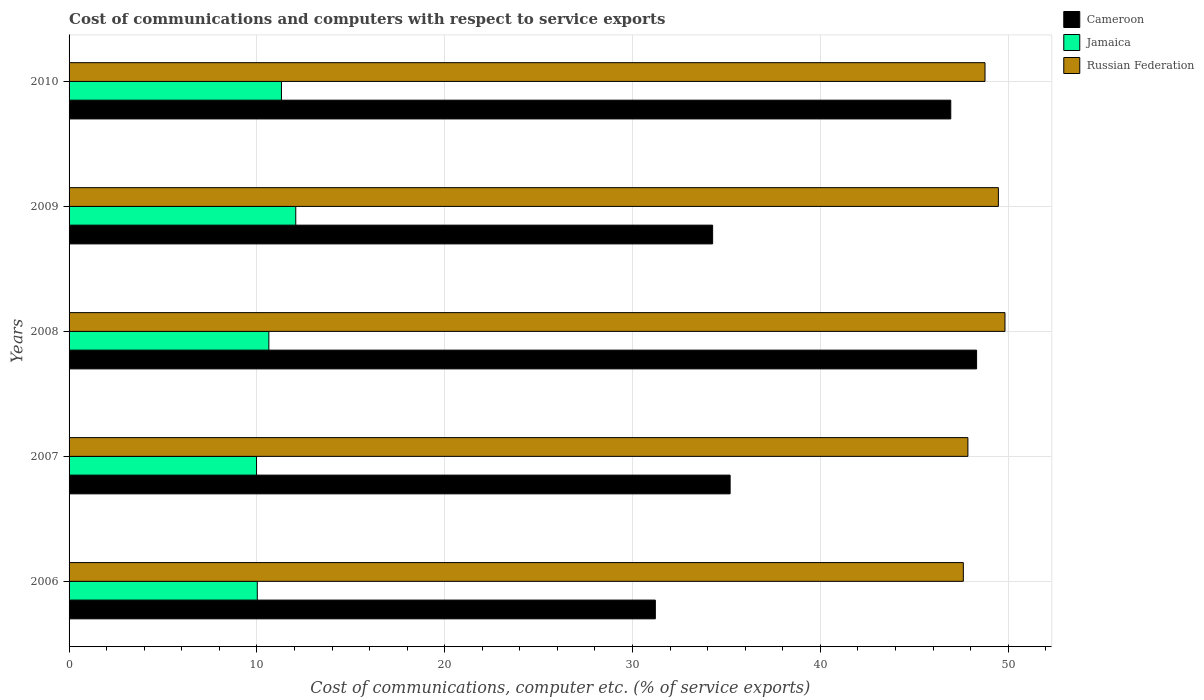How many different coloured bars are there?
Provide a succinct answer. 3. How many groups of bars are there?
Give a very brief answer. 5. How many bars are there on the 5th tick from the bottom?
Make the answer very short. 3. What is the label of the 4th group of bars from the top?
Your response must be concise. 2007. What is the cost of communications and computers in Jamaica in 2006?
Your response must be concise. 10.02. Across all years, what is the maximum cost of communications and computers in Russian Federation?
Offer a very short reply. 49.83. Across all years, what is the minimum cost of communications and computers in Jamaica?
Your response must be concise. 9.98. In which year was the cost of communications and computers in Russian Federation maximum?
Offer a very short reply. 2008. In which year was the cost of communications and computers in Cameroon minimum?
Your response must be concise. 2006. What is the total cost of communications and computers in Russian Federation in the graph?
Provide a succinct answer. 243.55. What is the difference between the cost of communications and computers in Cameroon in 2006 and that in 2007?
Your response must be concise. -3.98. What is the difference between the cost of communications and computers in Cameroon in 2006 and the cost of communications and computers in Russian Federation in 2007?
Offer a terse response. -16.64. What is the average cost of communications and computers in Russian Federation per year?
Make the answer very short. 48.71. In the year 2006, what is the difference between the cost of communications and computers in Jamaica and cost of communications and computers in Cameroon?
Ensure brevity in your answer.  -21.19. In how many years, is the cost of communications and computers in Russian Federation greater than 18 %?
Provide a succinct answer. 5. What is the ratio of the cost of communications and computers in Russian Federation in 2007 to that in 2009?
Make the answer very short. 0.97. Is the difference between the cost of communications and computers in Jamaica in 2007 and 2008 greater than the difference between the cost of communications and computers in Cameroon in 2007 and 2008?
Your answer should be compact. Yes. What is the difference between the highest and the second highest cost of communications and computers in Jamaica?
Your answer should be very brief. 0.76. What is the difference between the highest and the lowest cost of communications and computers in Jamaica?
Give a very brief answer. 2.09. In how many years, is the cost of communications and computers in Cameroon greater than the average cost of communications and computers in Cameroon taken over all years?
Provide a succinct answer. 2. What does the 3rd bar from the top in 2006 represents?
Provide a succinct answer. Cameroon. What does the 2nd bar from the bottom in 2008 represents?
Offer a very short reply. Jamaica. Is it the case that in every year, the sum of the cost of communications and computers in Russian Federation and cost of communications and computers in Cameroon is greater than the cost of communications and computers in Jamaica?
Make the answer very short. Yes. How many bars are there?
Your answer should be compact. 15. Are all the bars in the graph horizontal?
Give a very brief answer. Yes. How many years are there in the graph?
Your answer should be compact. 5. Does the graph contain any zero values?
Keep it short and to the point. No. What is the title of the graph?
Provide a short and direct response. Cost of communications and computers with respect to service exports. What is the label or title of the X-axis?
Provide a succinct answer. Cost of communications, computer etc. (% of service exports). What is the label or title of the Y-axis?
Your answer should be very brief. Years. What is the Cost of communications, computer etc. (% of service exports) of Cameroon in 2006?
Your response must be concise. 31.22. What is the Cost of communications, computer etc. (% of service exports) of Jamaica in 2006?
Your answer should be very brief. 10.02. What is the Cost of communications, computer etc. (% of service exports) of Russian Federation in 2006?
Your answer should be compact. 47.61. What is the Cost of communications, computer etc. (% of service exports) in Cameroon in 2007?
Your response must be concise. 35.2. What is the Cost of communications, computer etc. (% of service exports) of Jamaica in 2007?
Make the answer very short. 9.98. What is the Cost of communications, computer etc. (% of service exports) in Russian Federation in 2007?
Make the answer very short. 47.86. What is the Cost of communications, computer etc. (% of service exports) in Cameroon in 2008?
Your answer should be compact. 48.32. What is the Cost of communications, computer etc. (% of service exports) in Jamaica in 2008?
Offer a very short reply. 10.64. What is the Cost of communications, computer etc. (% of service exports) of Russian Federation in 2008?
Offer a very short reply. 49.83. What is the Cost of communications, computer etc. (% of service exports) in Cameroon in 2009?
Offer a very short reply. 34.27. What is the Cost of communications, computer etc. (% of service exports) of Jamaica in 2009?
Provide a succinct answer. 12.07. What is the Cost of communications, computer etc. (% of service exports) of Russian Federation in 2009?
Your answer should be compact. 49.48. What is the Cost of communications, computer etc. (% of service exports) in Cameroon in 2010?
Make the answer very short. 46.95. What is the Cost of communications, computer etc. (% of service exports) of Jamaica in 2010?
Offer a terse response. 11.31. What is the Cost of communications, computer etc. (% of service exports) in Russian Federation in 2010?
Offer a terse response. 48.77. Across all years, what is the maximum Cost of communications, computer etc. (% of service exports) of Cameroon?
Your answer should be very brief. 48.32. Across all years, what is the maximum Cost of communications, computer etc. (% of service exports) of Jamaica?
Your response must be concise. 12.07. Across all years, what is the maximum Cost of communications, computer etc. (% of service exports) in Russian Federation?
Offer a very short reply. 49.83. Across all years, what is the minimum Cost of communications, computer etc. (% of service exports) of Cameroon?
Offer a terse response. 31.22. Across all years, what is the minimum Cost of communications, computer etc. (% of service exports) of Jamaica?
Ensure brevity in your answer.  9.98. Across all years, what is the minimum Cost of communications, computer etc. (% of service exports) in Russian Federation?
Offer a terse response. 47.61. What is the total Cost of communications, computer etc. (% of service exports) of Cameroon in the graph?
Your answer should be very brief. 195.94. What is the total Cost of communications, computer etc. (% of service exports) of Jamaica in the graph?
Provide a succinct answer. 54.02. What is the total Cost of communications, computer etc. (% of service exports) of Russian Federation in the graph?
Offer a very short reply. 243.55. What is the difference between the Cost of communications, computer etc. (% of service exports) of Cameroon in 2006 and that in 2007?
Offer a terse response. -3.98. What is the difference between the Cost of communications, computer etc. (% of service exports) of Jamaica in 2006 and that in 2007?
Offer a very short reply. 0.04. What is the difference between the Cost of communications, computer etc. (% of service exports) in Russian Federation in 2006 and that in 2007?
Your answer should be compact. -0.24. What is the difference between the Cost of communications, computer etc. (% of service exports) of Cameroon in 2006 and that in 2008?
Offer a terse response. -17.11. What is the difference between the Cost of communications, computer etc. (% of service exports) of Jamaica in 2006 and that in 2008?
Make the answer very short. -0.62. What is the difference between the Cost of communications, computer etc. (% of service exports) in Russian Federation in 2006 and that in 2008?
Your answer should be very brief. -2.22. What is the difference between the Cost of communications, computer etc. (% of service exports) in Cameroon in 2006 and that in 2009?
Provide a succinct answer. -3.05. What is the difference between the Cost of communications, computer etc. (% of service exports) of Jamaica in 2006 and that in 2009?
Offer a very short reply. -2.05. What is the difference between the Cost of communications, computer etc. (% of service exports) of Russian Federation in 2006 and that in 2009?
Your response must be concise. -1.87. What is the difference between the Cost of communications, computer etc. (% of service exports) in Cameroon in 2006 and that in 2010?
Ensure brevity in your answer.  -15.73. What is the difference between the Cost of communications, computer etc. (% of service exports) in Jamaica in 2006 and that in 2010?
Give a very brief answer. -1.29. What is the difference between the Cost of communications, computer etc. (% of service exports) of Russian Federation in 2006 and that in 2010?
Provide a succinct answer. -1.15. What is the difference between the Cost of communications, computer etc. (% of service exports) of Cameroon in 2007 and that in 2008?
Your answer should be compact. -13.12. What is the difference between the Cost of communications, computer etc. (% of service exports) in Jamaica in 2007 and that in 2008?
Ensure brevity in your answer.  -0.66. What is the difference between the Cost of communications, computer etc. (% of service exports) in Russian Federation in 2007 and that in 2008?
Provide a short and direct response. -1.97. What is the difference between the Cost of communications, computer etc. (% of service exports) in Cameroon in 2007 and that in 2009?
Offer a terse response. 0.93. What is the difference between the Cost of communications, computer etc. (% of service exports) in Jamaica in 2007 and that in 2009?
Provide a succinct answer. -2.09. What is the difference between the Cost of communications, computer etc. (% of service exports) in Russian Federation in 2007 and that in 2009?
Your answer should be very brief. -1.62. What is the difference between the Cost of communications, computer etc. (% of service exports) of Cameroon in 2007 and that in 2010?
Give a very brief answer. -11.75. What is the difference between the Cost of communications, computer etc. (% of service exports) of Jamaica in 2007 and that in 2010?
Your answer should be very brief. -1.33. What is the difference between the Cost of communications, computer etc. (% of service exports) of Russian Federation in 2007 and that in 2010?
Provide a succinct answer. -0.91. What is the difference between the Cost of communications, computer etc. (% of service exports) of Cameroon in 2008 and that in 2009?
Your response must be concise. 14.05. What is the difference between the Cost of communications, computer etc. (% of service exports) of Jamaica in 2008 and that in 2009?
Your answer should be compact. -1.43. What is the difference between the Cost of communications, computer etc. (% of service exports) in Russian Federation in 2008 and that in 2009?
Ensure brevity in your answer.  0.35. What is the difference between the Cost of communications, computer etc. (% of service exports) in Cameroon in 2008 and that in 2010?
Provide a short and direct response. 1.38. What is the difference between the Cost of communications, computer etc. (% of service exports) in Jamaica in 2008 and that in 2010?
Make the answer very short. -0.67. What is the difference between the Cost of communications, computer etc. (% of service exports) of Russian Federation in 2008 and that in 2010?
Your answer should be very brief. 1.06. What is the difference between the Cost of communications, computer etc. (% of service exports) in Cameroon in 2009 and that in 2010?
Ensure brevity in your answer.  -12.68. What is the difference between the Cost of communications, computer etc. (% of service exports) of Jamaica in 2009 and that in 2010?
Ensure brevity in your answer.  0.76. What is the difference between the Cost of communications, computer etc. (% of service exports) of Russian Federation in 2009 and that in 2010?
Provide a succinct answer. 0.71. What is the difference between the Cost of communications, computer etc. (% of service exports) in Cameroon in 2006 and the Cost of communications, computer etc. (% of service exports) in Jamaica in 2007?
Keep it short and to the point. 21.23. What is the difference between the Cost of communications, computer etc. (% of service exports) in Cameroon in 2006 and the Cost of communications, computer etc. (% of service exports) in Russian Federation in 2007?
Provide a short and direct response. -16.64. What is the difference between the Cost of communications, computer etc. (% of service exports) in Jamaica in 2006 and the Cost of communications, computer etc. (% of service exports) in Russian Federation in 2007?
Provide a short and direct response. -37.84. What is the difference between the Cost of communications, computer etc. (% of service exports) in Cameroon in 2006 and the Cost of communications, computer etc. (% of service exports) in Jamaica in 2008?
Provide a short and direct response. 20.58. What is the difference between the Cost of communications, computer etc. (% of service exports) of Cameroon in 2006 and the Cost of communications, computer etc. (% of service exports) of Russian Federation in 2008?
Provide a short and direct response. -18.62. What is the difference between the Cost of communications, computer etc. (% of service exports) of Jamaica in 2006 and the Cost of communications, computer etc. (% of service exports) of Russian Federation in 2008?
Your response must be concise. -39.81. What is the difference between the Cost of communications, computer etc. (% of service exports) of Cameroon in 2006 and the Cost of communications, computer etc. (% of service exports) of Jamaica in 2009?
Offer a terse response. 19.15. What is the difference between the Cost of communications, computer etc. (% of service exports) in Cameroon in 2006 and the Cost of communications, computer etc. (% of service exports) in Russian Federation in 2009?
Offer a terse response. -18.27. What is the difference between the Cost of communications, computer etc. (% of service exports) of Jamaica in 2006 and the Cost of communications, computer etc. (% of service exports) of Russian Federation in 2009?
Give a very brief answer. -39.46. What is the difference between the Cost of communications, computer etc. (% of service exports) of Cameroon in 2006 and the Cost of communications, computer etc. (% of service exports) of Jamaica in 2010?
Your answer should be very brief. 19.91. What is the difference between the Cost of communications, computer etc. (% of service exports) of Cameroon in 2006 and the Cost of communications, computer etc. (% of service exports) of Russian Federation in 2010?
Ensure brevity in your answer.  -17.55. What is the difference between the Cost of communications, computer etc. (% of service exports) of Jamaica in 2006 and the Cost of communications, computer etc. (% of service exports) of Russian Federation in 2010?
Ensure brevity in your answer.  -38.75. What is the difference between the Cost of communications, computer etc. (% of service exports) in Cameroon in 2007 and the Cost of communications, computer etc. (% of service exports) in Jamaica in 2008?
Make the answer very short. 24.56. What is the difference between the Cost of communications, computer etc. (% of service exports) in Cameroon in 2007 and the Cost of communications, computer etc. (% of service exports) in Russian Federation in 2008?
Provide a short and direct response. -14.63. What is the difference between the Cost of communications, computer etc. (% of service exports) in Jamaica in 2007 and the Cost of communications, computer etc. (% of service exports) in Russian Federation in 2008?
Provide a succinct answer. -39.85. What is the difference between the Cost of communications, computer etc. (% of service exports) of Cameroon in 2007 and the Cost of communications, computer etc. (% of service exports) of Jamaica in 2009?
Provide a short and direct response. 23.13. What is the difference between the Cost of communications, computer etc. (% of service exports) of Cameroon in 2007 and the Cost of communications, computer etc. (% of service exports) of Russian Federation in 2009?
Offer a terse response. -14.28. What is the difference between the Cost of communications, computer etc. (% of service exports) of Jamaica in 2007 and the Cost of communications, computer etc. (% of service exports) of Russian Federation in 2009?
Your answer should be compact. -39.5. What is the difference between the Cost of communications, computer etc. (% of service exports) of Cameroon in 2007 and the Cost of communications, computer etc. (% of service exports) of Jamaica in 2010?
Make the answer very short. 23.89. What is the difference between the Cost of communications, computer etc. (% of service exports) of Cameroon in 2007 and the Cost of communications, computer etc. (% of service exports) of Russian Federation in 2010?
Your answer should be compact. -13.57. What is the difference between the Cost of communications, computer etc. (% of service exports) of Jamaica in 2007 and the Cost of communications, computer etc. (% of service exports) of Russian Federation in 2010?
Your answer should be very brief. -38.79. What is the difference between the Cost of communications, computer etc. (% of service exports) of Cameroon in 2008 and the Cost of communications, computer etc. (% of service exports) of Jamaica in 2009?
Your response must be concise. 36.25. What is the difference between the Cost of communications, computer etc. (% of service exports) of Cameroon in 2008 and the Cost of communications, computer etc. (% of service exports) of Russian Federation in 2009?
Offer a very short reply. -1.16. What is the difference between the Cost of communications, computer etc. (% of service exports) in Jamaica in 2008 and the Cost of communications, computer etc. (% of service exports) in Russian Federation in 2009?
Give a very brief answer. -38.84. What is the difference between the Cost of communications, computer etc. (% of service exports) in Cameroon in 2008 and the Cost of communications, computer etc. (% of service exports) in Jamaica in 2010?
Your response must be concise. 37.01. What is the difference between the Cost of communications, computer etc. (% of service exports) in Cameroon in 2008 and the Cost of communications, computer etc. (% of service exports) in Russian Federation in 2010?
Provide a short and direct response. -0.45. What is the difference between the Cost of communications, computer etc. (% of service exports) in Jamaica in 2008 and the Cost of communications, computer etc. (% of service exports) in Russian Federation in 2010?
Offer a terse response. -38.13. What is the difference between the Cost of communications, computer etc. (% of service exports) in Cameroon in 2009 and the Cost of communications, computer etc. (% of service exports) in Jamaica in 2010?
Give a very brief answer. 22.96. What is the difference between the Cost of communications, computer etc. (% of service exports) of Cameroon in 2009 and the Cost of communications, computer etc. (% of service exports) of Russian Federation in 2010?
Offer a very short reply. -14.5. What is the difference between the Cost of communications, computer etc. (% of service exports) in Jamaica in 2009 and the Cost of communications, computer etc. (% of service exports) in Russian Federation in 2010?
Make the answer very short. -36.7. What is the average Cost of communications, computer etc. (% of service exports) of Cameroon per year?
Your response must be concise. 39.19. What is the average Cost of communications, computer etc. (% of service exports) of Jamaica per year?
Your answer should be very brief. 10.8. What is the average Cost of communications, computer etc. (% of service exports) in Russian Federation per year?
Your answer should be compact. 48.71. In the year 2006, what is the difference between the Cost of communications, computer etc. (% of service exports) of Cameroon and Cost of communications, computer etc. (% of service exports) of Jamaica?
Provide a short and direct response. 21.19. In the year 2006, what is the difference between the Cost of communications, computer etc. (% of service exports) of Cameroon and Cost of communications, computer etc. (% of service exports) of Russian Federation?
Your answer should be compact. -16.4. In the year 2006, what is the difference between the Cost of communications, computer etc. (% of service exports) of Jamaica and Cost of communications, computer etc. (% of service exports) of Russian Federation?
Your answer should be compact. -37.59. In the year 2007, what is the difference between the Cost of communications, computer etc. (% of service exports) of Cameroon and Cost of communications, computer etc. (% of service exports) of Jamaica?
Keep it short and to the point. 25.22. In the year 2007, what is the difference between the Cost of communications, computer etc. (% of service exports) of Cameroon and Cost of communications, computer etc. (% of service exports) of Russian Federation?
Your answer should be compact. -12.66. In the year 2007, what is the difference between the Cost of communications, computer etc. (% of service exports) of Jamaica and Cost of communications, computer etc. (% of service exports) of Russian Federation?
Offer a terse response. -37.88. In the year 2008, what is the difference between the Cost of communications, computer etc. (% of service exports) of Cameroon and Cost of communications, computer etc. (% of service exports) of Jamaica?
Offer a very short reply. 37.68. In the year 2008, what is the difference between the Cost of communications, computer etc. (% of service exports) of Cameroon and Cost of communications, computer etc. (% of service exports) of Russian Federation?
Ensure brevity in your answer.  -1.51. In the year 2008, what is the difference between the Cost of communications, computer etc. (% of service exports) of Jamaica and Cost of communications, computer etc. (% of service exports) of Russian Federation?
Offer a terse response. -39.19. In the year 2009, what is the difference between the Cost of communications, computer etc. (% of service exports) in Cameroon and Cost of communications, computer etc. (% of service exports) in Jamaica?
Keep it short and to the point. 22.2. In the year 2009, what is the difference between the Cost of communications, computer etc. (% of service exports) in Cameroon and Cost of communications, computer etc. (% of service exports) in Russian Federation?
Offer a very short reply. -15.21. In the year 2009, what is the difference between the Cost of communications, computer etc. (% of service exports) of Jamaica and Cost of communications, computer etc. (% of service exports) of Russian Federation?
Give a very brief answer. -37.41. In the year 2010, what is the difference between the Cost of communications, computer etc. (% of service exports) in Cameroon and Cost of communications, computer etc. (% of service exports) in Jamaica?
Your answer should be compact. 35.64. In the year 2010, what is the difference between the Cost of communications, computer etc. (% of service exports) in Cameroon and Cost of communications, computer etc. (% of service exports) in Russian Federation?
Your answer should be compact. -1.82. In the year 2010, what is the difference between the Cost of communications, computer etc. (% of service exports) in Jamaica and Cost of communications, computer etc. (% of service exports) in Russian Federation?
Ensure brevity in your answer.  -37.46. What is the ratio of the Cost of communications, computer etc. (% of service exports) of Cameroon in 2006 to that in 2007?
Give a very brief answer. 0.89. What is the ratio of the Cost of communications, computer etc. (% of service exports) of Russian Federation in 2006 to that in 2007?
Provide a short and direct response. 0.99. What is the ratio of the Cost of communications, computer etc. (% of service exports) of Cameroon in 2006 to that in 2008?
Your answer should be compact. 0.65. What is the ratio of the Cost of communications, computer etc. (% of service exports) in Jamaica in 2006 to that in 2008?
Make the answer very short. 0.94. What is the ratio of the Cost of communications, computer etc. (% of service exports) in Russian Federation in 2006 to that in 2008?
Your answer should be compact. 0.96. What is the ratio of the Cost of communications, computer etc. (% of service exports) of Cameroon in 2006 to that in 2009?
Give a very brief answer. 0.91. What is the ratio of the Cost of communications, computer etc. (% of service exports) of Jamaica in 2006 to that in 2009?
Give a very brief answer. 0.83. What is the ratio of the Cost of communications, computer etc. (% of service exports) of Russian Federation in 2006 to that in 2009?
Offer a terse response. 0.96. What is the ratio of the Cost of communications, computer etc. (% of service exports) of Cameroon in 2006 to that in 2010?
Offer a terse response. 0.66. What is the ratio of the Cost of communications, computer etc. (% of service exports) of Jamaica in 2006 to that in 2010?
Your response must be concise. 0.89. What is the ratio of the Cost of communications, computer etc. (% of service exports) of Russian Federation in 2006 to that in 2010?
Your answer should be very brief. 0.98. What is the ratio of the Cost of communications, computer etc. (% of service exports) of Cameroon in 2007 to that in 2008?
Keep it short and to the point. 0.73. What is the ratio of the Cost of communications, computer etc. (% of service exports) of Jamaica in 2007 to that in 2008?
Offer a very short reply. 0.94. What is the ratio of the Cost of communications, computer etc. (% of service exports) in Russian Federation in 2007 to that in 2008?
Provide a short and direct response. 0.96. What is the ratio of the Cost of communications, computer etc. (% of service exports) of Cameroon in 2007 to that in 2009?
Make the answer very short. 1.03. What is the ratio of the Cost of communications, computer etc. (% of service exports) in Jamaica in 2007 to that in 2009?
Offer a terse response. 0.83. What is the ratio of the Cost of communications, computer etc. (% of service exports) of Russian Federation in 2007 to that in 2009?
Make the answer very short. 0.97. What is the ratio of the Cost of communications, computer etc. (% of service exports) in Cameroon in 2007 to that in 2010?
Offer a very short reply. 0.75. What is the ratio of the Cost of communications, computer etc. (% of service exports) of Jamaica in 2007 to that in 2010?
Ensure brevity in your answer.  0.88. What is the ratio of the Cost of communications, computer etc. (% of service exports) in Russian Federation in 2007 to that in 2010?
Offer a terse response. 0.98. What is the ratio of the Cost of communications, computer etc. (% of service exports) of Cameroon in 2008 to that in 2009?
Give a very brief answer. 1.41. What is the ratio of the Cost of communications, computer etc. (% of service exports) of Jamaica in 2008 to that in 2009?
Your response must be concise. 0.88. What is the ratio of the Cost of communications, computer etc. (% of service exports) in Russian Federation in 2008 to that in 2009?
Give a very brief answer. 1.01. What is the ratio of the Cost of communications, computer etc. (% of service exports) in Cameroon in 2008 to that in 2010?
Your response must be concise. 1.03. What is the ratio of the Cost of communications, computer etc. (% of service exports) of Jamaica in 2008 to that in 2010?
Ensure brevity in your answer.  0.94. What is the ratio of the Cost of communications, computer etc. (% of service exports) of Russian Federation in 2008 to that in 2010?
Provide a succinct answer. 1.02. What is the ratio of the Cost of communications, computer etc. (% of service exports) of Cameroon in 2009 to that in 2010?
Provide a short and direct response. 0.73. What is the ratio of the Cost of communications, computer etc. (% of service exports) of Jamaica in 2009 to that in 2010?
Your answer should be very brief. 1.07. What is the ratio of the Cost of communications, computer etc. (% of service exports) in Russian Federation in 2009 to that in 2010?
Your answer should be compact. 1.01. What is the difference between the highest and the second highest Cost of communications, computer etc. (% of service exports) in Cameroon?
Provide a short and direct response. 1.38. What is the difference between the highest and the second highest Cost of communications, computer etc. (% of service exports) in Jamaica?
Make the answer very short. 0.76. What is the difference between the highest and the second highest Cost of communications, computer etc. (% of service exports) of Russian Federation?
Provide a succinct answer. 0.35. What is the difference between the highest and the lowest Cost of communications, computer etc. (% of service exports) in Cameroon?
Provide a succinct answer. 17.11. What is the difference between the highest and the lowest Cost of communications, computer etc. (% of service exports) in Jamaica?
Ensure brevity in your answer.  2.09. What is the difference between the highest and the lowest Cost of communications, computer etc. (% of service exports) of Russian Federation?
Your response must be concise. 2.22. 